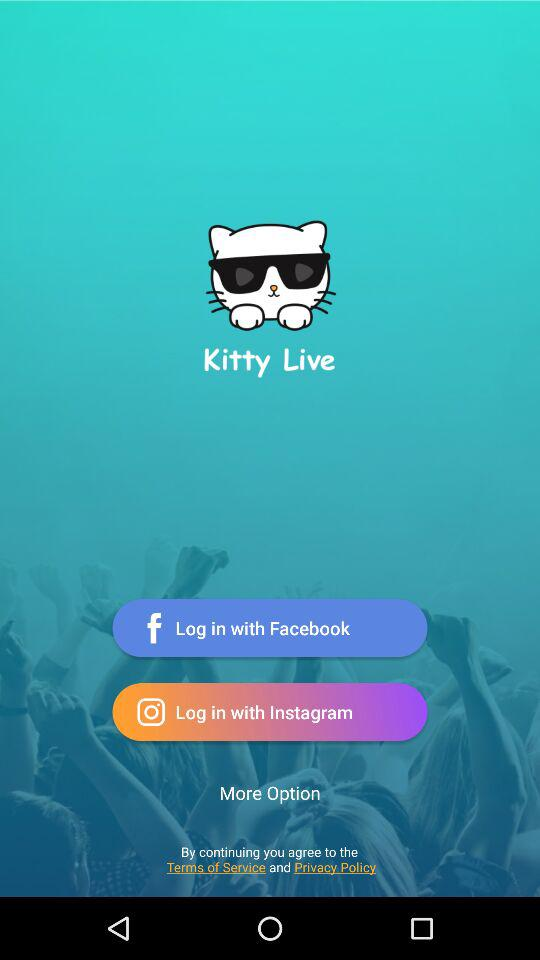What are the different applications through which we can log in? The different applications through which we can log in are "Facebook" and "Instagram". 